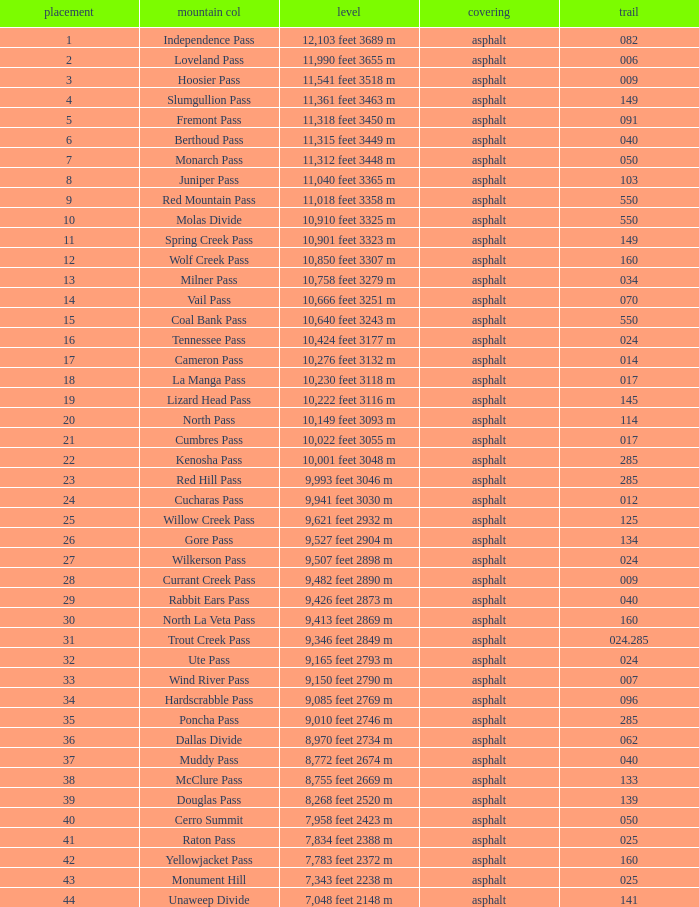What is the Elevation of the mountain on Route 62? 8,970 feet 2734 m. 